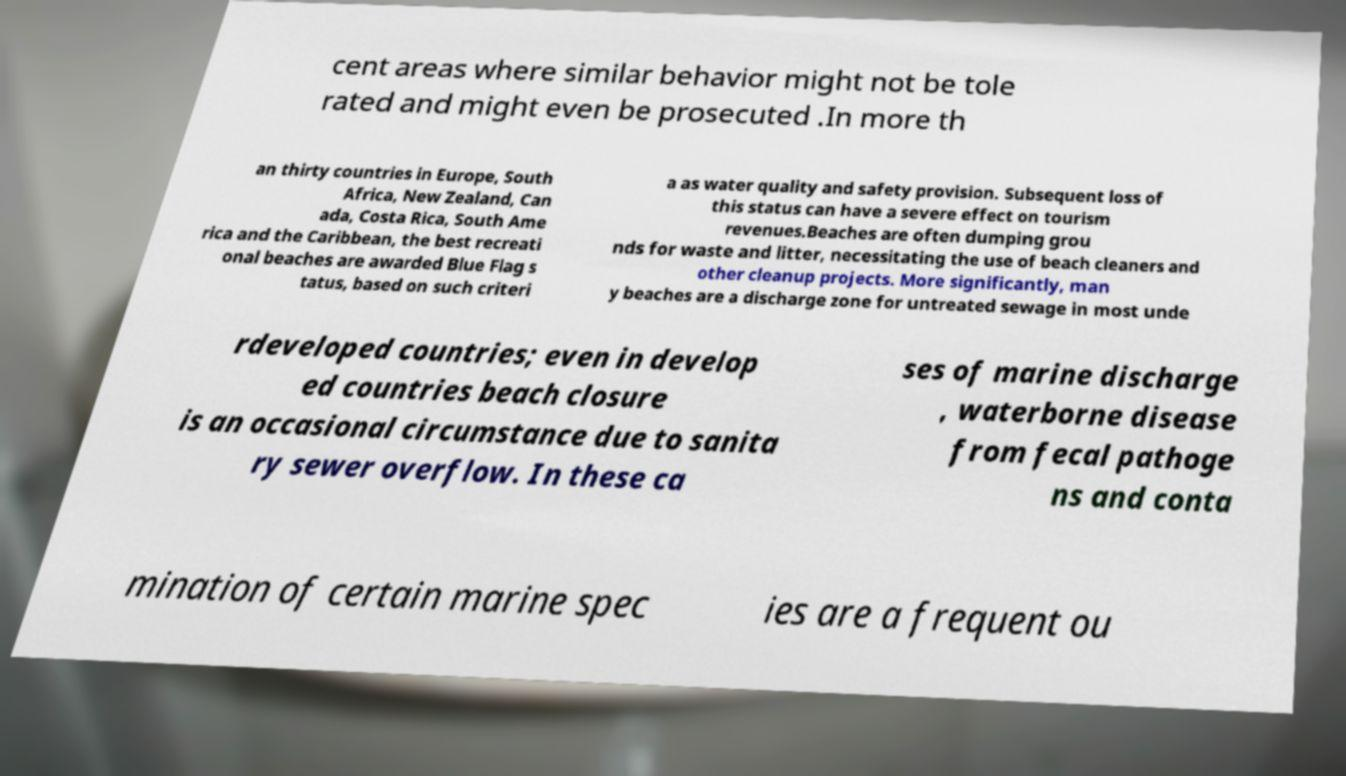Could you extract and type out the text from this image? cent areas where similar behavior might not be tole rated and might even be prosecuted .In more th an thirty countries in Europe, South Africa, New Zealand, Can ada, Costa Rica, South Ame rica and the Caribbean, the best recreati onal beaches are awarded Blue Flag s tatus, based on such criteri a as water quality and safety provision. Subsequent loss of this status can have a severe effect on tourism revenues.Beaches are often dumping grou nds for waste and litter, necessitating the use of beach cleaners and other cleanup projects. More significantly, man y beaches are a discharge zone for untreated sewage in most unde rdeveloped countries; even in develop ed countries beach closure is an occasional circumstance due to sanita ry sewer overflow. In these ca ses of marine discharge , waterborne disease from fecal pathoge ns and conta mination of certain marine spec ies are a frequent ou 